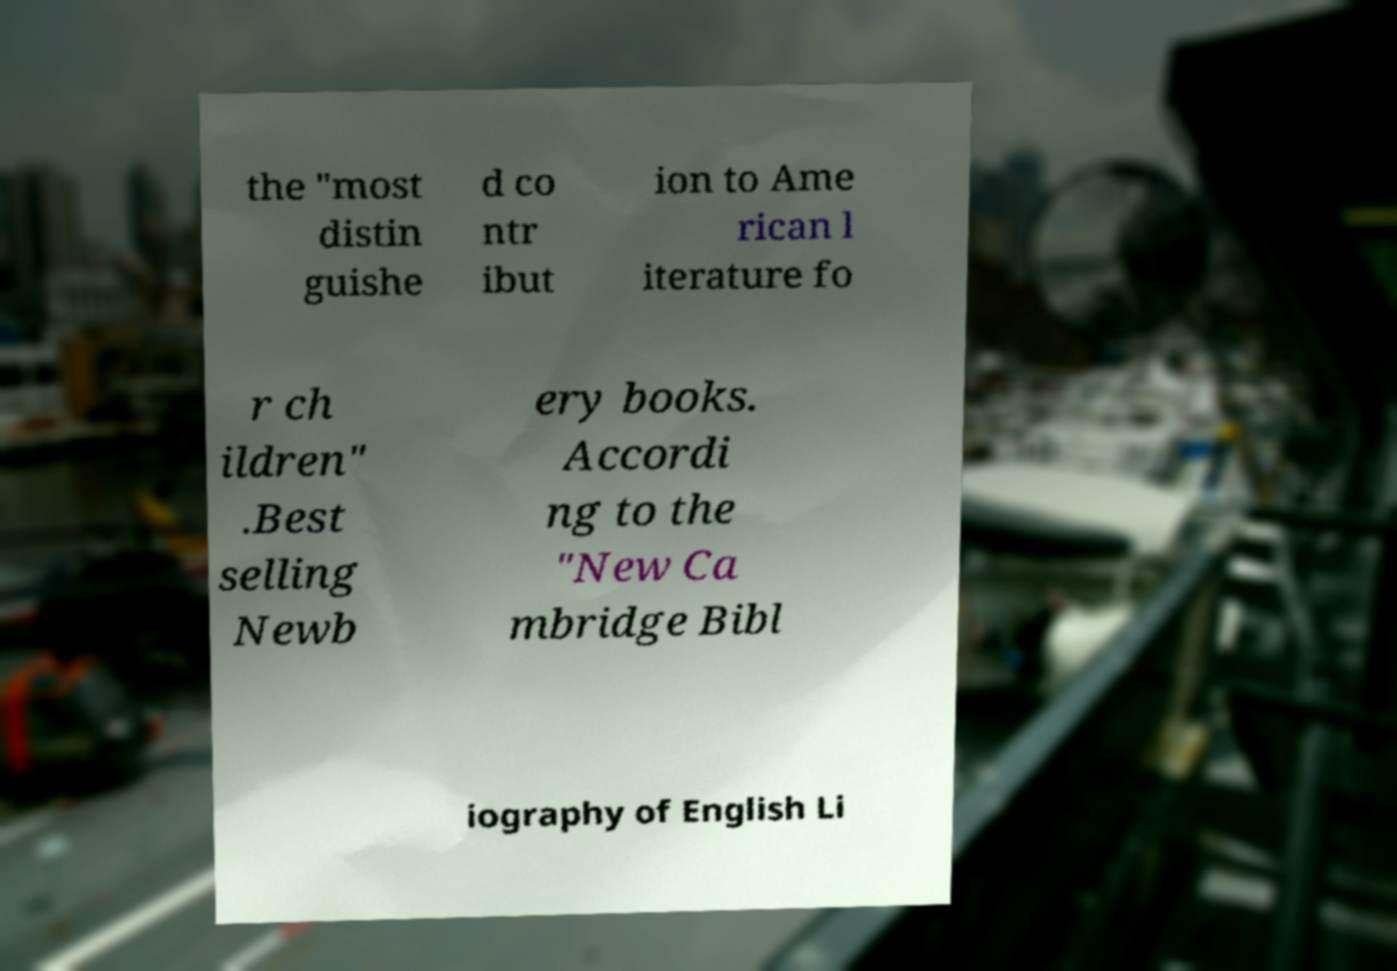Can you accurately transcribe the text from the provided image for me? the "most distin guishe d co ntr ibut ion to Ame rican l iterature fo r ch ildren" .Best selling Newb ery books. Accordi ng to the "New Ca mbridge Bibl iography of English Li 